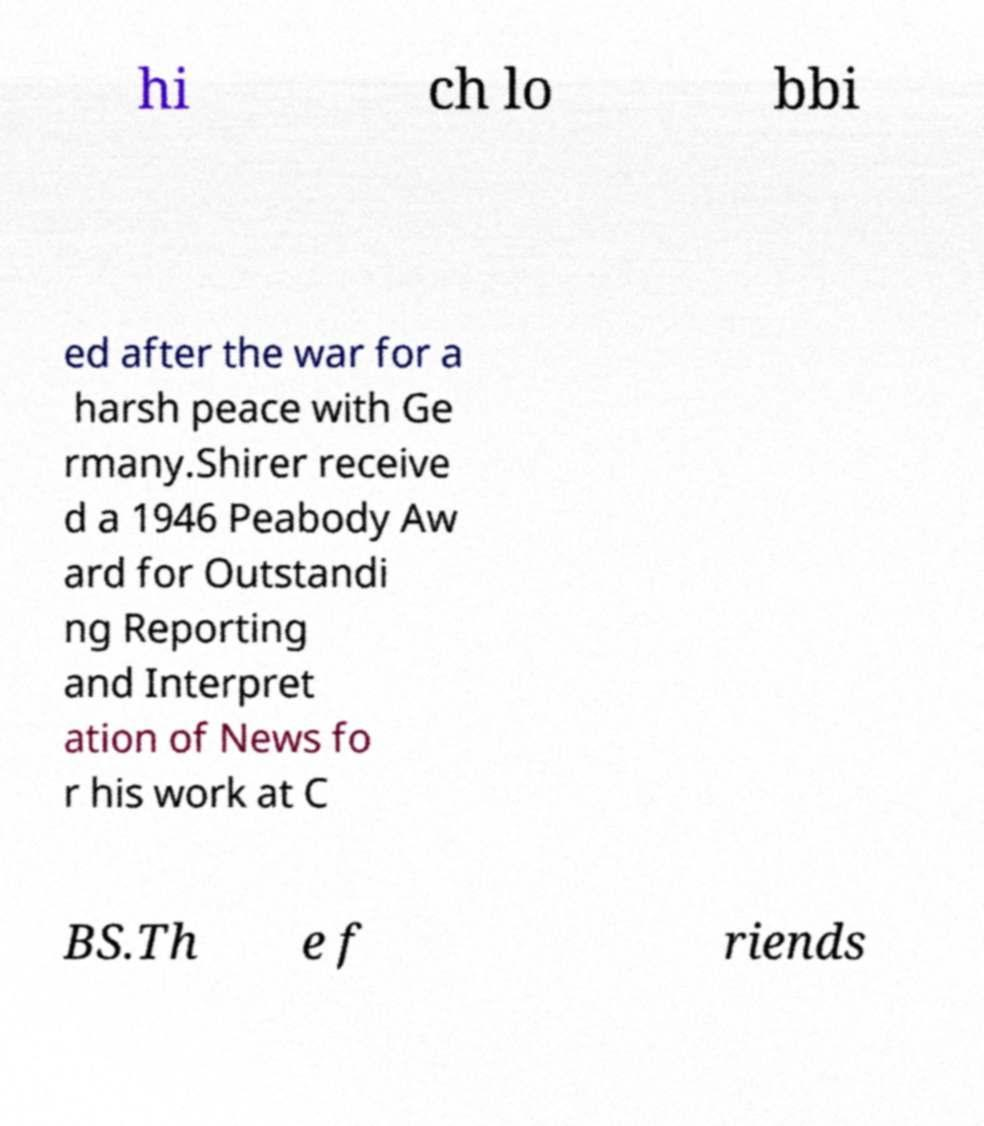Please identify and transcribe the text found in this image. hi ch lo bbi ed after the war for a harsh peace with Ge rmany.Shirer receive d a 1946 Peabody Aw ard for Outstandi ng Reporting and Interpret ation of News fo r his work at C BS.Th e f riends 